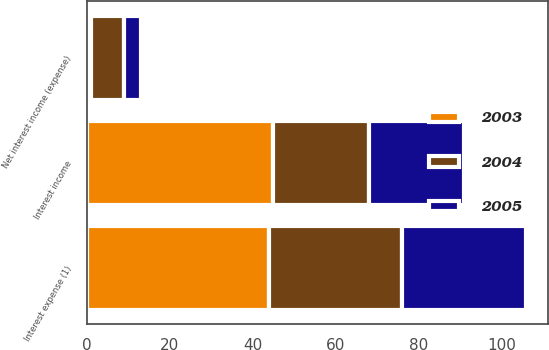Convert chart. <chart><loc_0><loc_0><loc_500><loc_500><stacked_bar_chart><ecel><fcel>Interest expense (1)<fcel>Interest income<fcel>Net interest income (expense)<nl><fcel>2003<fcel>44<fcel>45<fcel>1<nl><fcel>2004<fcel>32<fcel>23<fcel>8<nl><fcel>2005<fcel>30<fcel>23<fcel>4<nl></chart> 